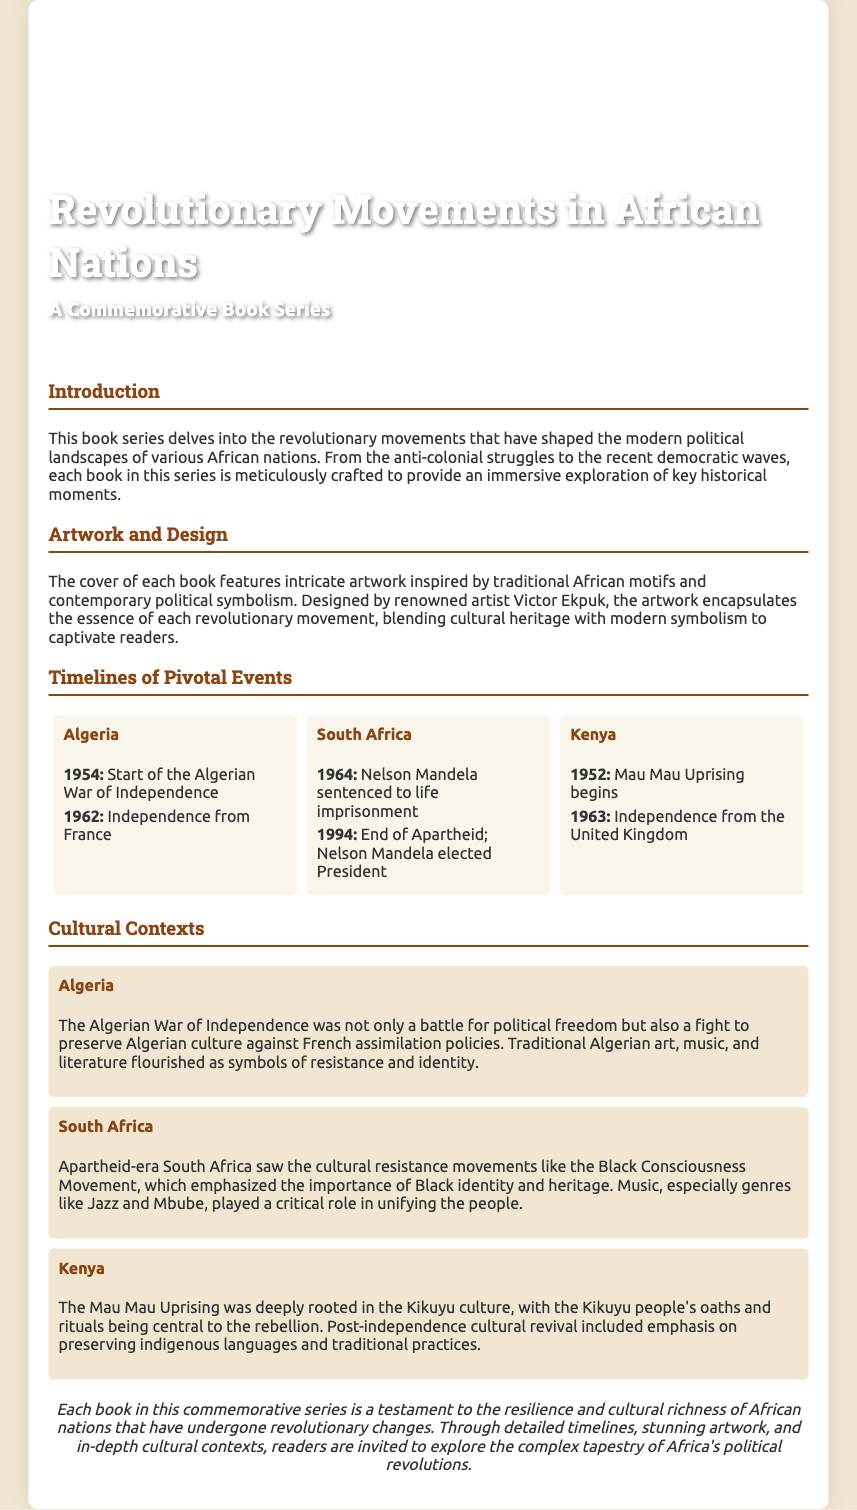what is the title of the book series? The title of the book series is prominently displayed on the cover.
Answer: Revolutionary Movements in African Nations who designed the artwork for the books? The document mentions a renowned artist responsible for the book series’ artwork.
Answer: Victor Ekpuk what year did the Algerian War of Independence start? The timeline section lists the key events along with their respective dates.
Answer: 1954 which significant event occurred in South Africa in 1994? The timeline for South Africa indicates a crucial milestone in its political history.
Answer: End of Apartheid; Nelson Mandela elected President what was a cultural aspect of the Mau Mau Uprising in Kenya? The cultural context section provides insight into the cultural elements tied to the movement.
Answer: Kikuyu people's oaths and rituals how does the book series present cultural movements in the context of political changes? The introduction discusses how the series explores the interplay between culture and revolution.
Answer: Immersive exploration which country’s independence from the United Kingdom is noted in 1963? The provided timelines in the document highlight pivotal years of independence for different nations.
Answer: Kenya what type of motifs is used in the book cover design? The artwork and design section describes the visual inspiration behind the covers.
Answer: Traditional African motifs 